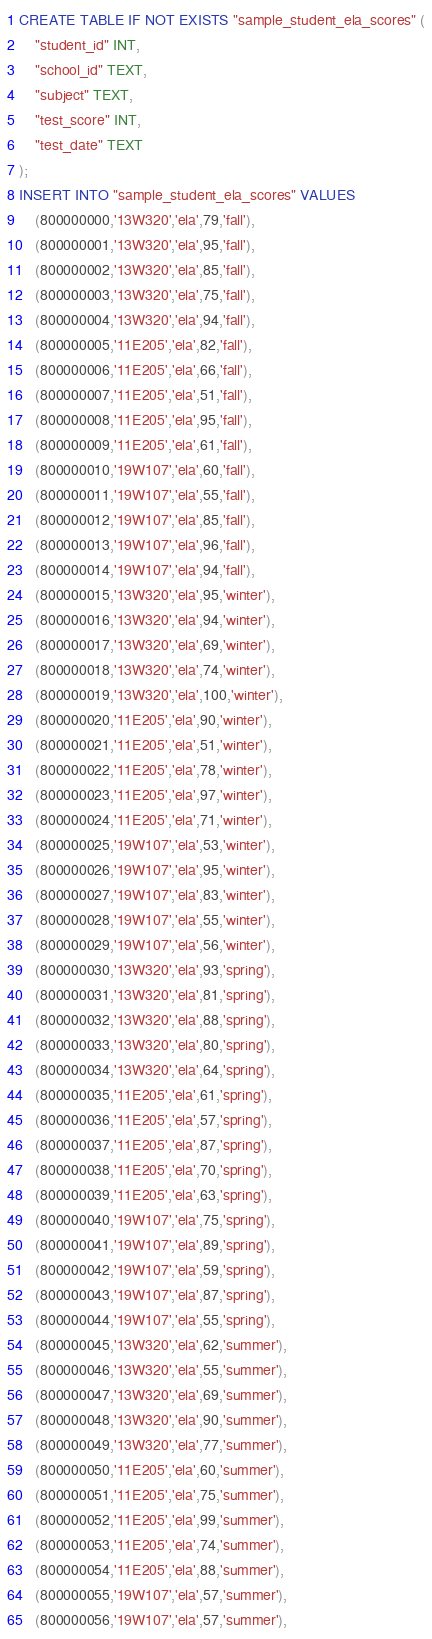Convert code to text. <code><loc_0><loc_0><loc_500><loc_500><_SQL_>CREATE TABLE IF NOT EXISTS "sample_student_ela_scores" (
    "student_id" INT,
    "school_id" TEXT,
    "subject" TEXT,
    "test_score" INT,
    "test_date" TEXT
);
INSERT INTO "sample_student_ela_scores" VALUES
    (800000000,'13W320','ela',79,'fall'),
    (800000001,'13W320','ela',95,'fall'),
    (800000002,'13W320','ela',85,'fall'),
    (800000003,'13W320','ela',75,'fall'),
    (800000004,'13W320','ela',94,'fall'),
    (800000005,'11E205','ela',82,'fall'),
    (800000006,'11E205','ela',66,'fall'),
    (800000007,'11E205','ela',51,'fall'),
    (800000008,'11E205','ela',95,'fall'),
    (800000009,'11E205','ela',61,'fall'),
    (800000010,'19W107','ela',60,'fall'),
    (800000011,'19W107','ela',55,'fall'),
    (800000012,'19W107','ela',85,'fall'),
    (800000013,'19W107','ela',96,'fall'),
    (800000014,'19W107','ela',94,'fall'),
    (800000015,'13W320','ela',95,'winter'),
    (800000016,'13W320','ela',94,'winter'),
    (800000017,'13W320','ela',69,'winter'),
    (800000018,'13W320','ela',74,'winter'),
    (800000019,'13W320','ela',100,'winter'),
    (800000020,'11E205','ela',90,'winter'),
    (800000021,'11E205','ela',51,'winter'),
    (800000022,'11E205','ela',78,'winter'),
    (800000023,'11E205','ela',97,'winter'),
    (800000024,'11E205','ela',71,'winter'),
    (800000025,'19W107','ela',53,'winter'),
    (800000026,'19W107','ela',95,'winter'),
    (800000027,'19W107','ela',83,'winter'),
    (800000028,'19W107','ela',55,'winter'),
    (800000029,'19W107','ela',56,'winter'),
    (800000030,'13W320','ela',93,'spring'),
    (800000031,'13W320','ela',81,'spring'),
    (800000032,'13W320','ela',88,'spring'),
    (800000033,'13W320','ela',80,'spring'),
    (800000034,'13W320','ela',64,'spring'),
    (800000035,'11E205','ela',61,'spring'),
    (800000036,'11E205','ela',57,'spring'),
    (800000037,'11E205','ela',87,'spring'),
    (800000038,'11E205','ela',70,'spring'),
    (800000039,'11E205','ela',63,'spring'),
    (800000040,'19W107','ela',75,'spring'),
    (800000041,'19W107','ela',89,'spring'),
    (800000042,'19W107','ela',59,'spring'),
    (800000043,'19W107','ela',87,'spring'),
    (800000044,'19W107','ela',55,'spring'),
    (800000045,'13W320','ela',62,'summer'),
    (800000046,'13W320','ela',55,'summer'),
    (800000047,'13W320','ela',69,'summer'),
    (800000048,'13W320','ela',90,'summer'),
    (800000049,'13W320','ela',77,'summer'),
    (800000050,'11E205','ela',60,'summer'),
    (800000051,'11E205','ela',75,'summer'),
    (800000052,'11E205','ela',99,'summer'),
    (800000053,'11E205','ela',74,'summer'),
    (800000054,'11E205','ela',88,'summer'),
    (800000055,'19W107','ela',57,'summer'),
    (800000056,'19W107','ela',57,'summer'),</code> 